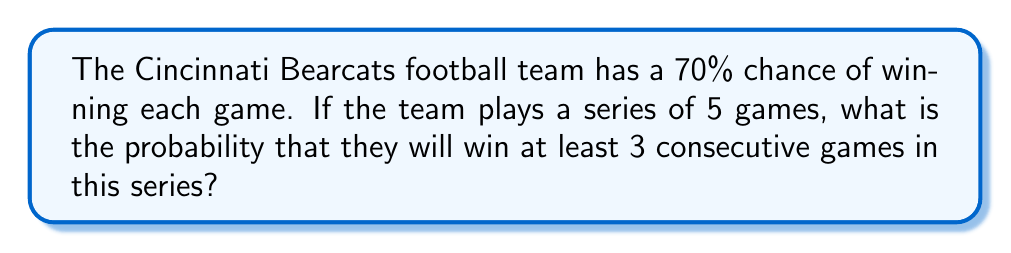Give your solution to this math problem. Let's approach this step-by-step:

1) First, we need to identify all the possible ways to win at least 3 consecutive games in a 5-game series. The possibilities are:
   - WWWLL, LWWWL, LLWWW, WWWWL, LWWWW, WWWWW
   Where W represents a win and L represents a loss.

2) Now, let's calculate the probability of each scenario:
   
   For WWWLL: $P(WWWLL) = 0.7 \times 0.7 \times 0.7 \times 0.3 \times 0.3 = 0.7^3 \times 0.3^2$
   
   Similarly for LWWWL: $P(LWWWL) = 0.3 \times 0.7^3 \times 0.3$
   
   For LLWWW: $P(LLWWW) = 0.3^2 \times 0.7^3$
   
   For WWWWL: $P(WWWWL) = 0.7^4 \times 0.3$
   
   For LWWWW: $P(LWWWW) = 0.3 \times 0.7^4$
   
   For WWWWW: $P(WWWWW) = 0.7^5$

3) The total probability is the sum of all these individual probabilities:

   $$P(\text{at least 3 consecutive wins}) = 3(0.7^3 \times 0.3^2) + 2(0.7^4 \times 0.3) + 0.7^5$$

4) Let's calculate this:
   
   $$\begin{align}
   P &= 3(0.343 \times 0.09) + 2(0.2401 \times 0.3) + 0.16807 \\
   &= 3(0.03087) + 2(0.07203) + 0.16807 \\
   &= 0.09261 + 0.14406 + 0.16807 \\
   &= 0.40474
   \end{align}$$

Therefore, the probability of winning at least 3 consecutive games in a 5-game series is approximately 0.40474 or 40.474%.
Answer: $0.40474$ or $40.474\%$ 